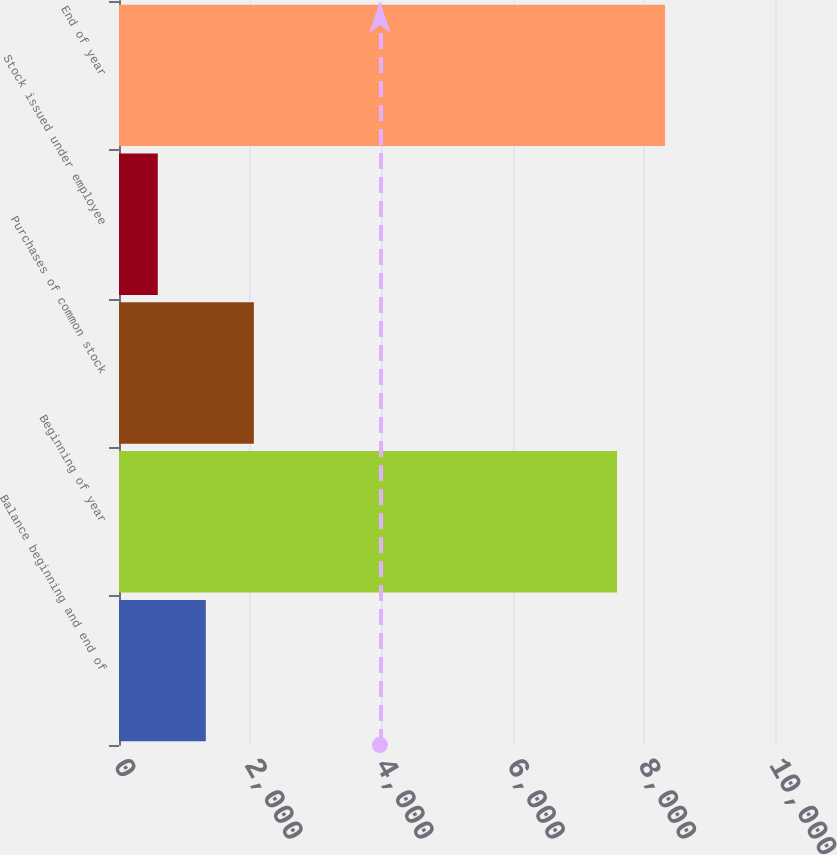Convert chart to OTSL. <chart><loc_0><loc_0><loc_500><loc_500><bar_chart><fcel>Balance beginning and end of<fcel>Beginning of year<fcel>Purchases of common stock<fcel>Stock issued under employee<fcel>End of year<nl><fcel>1323.3<fcel>7592<fcel>2055.6<fcel>591<fcel>8324.3<nl></chart> 